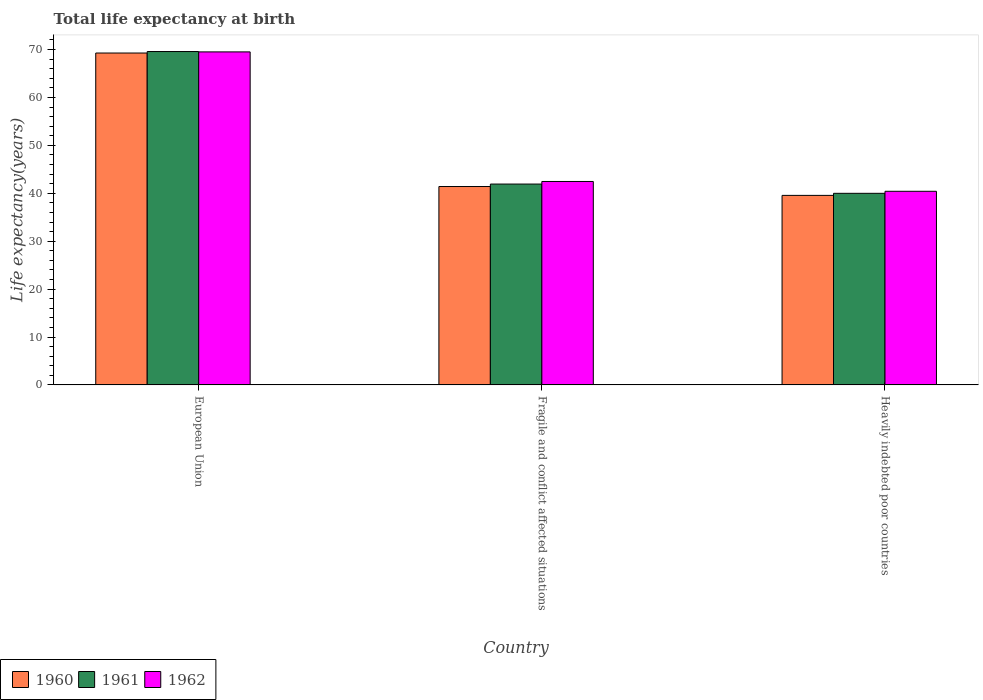How many groups of bars are there?
Offer a very short reply. 3. Are the number of bars on each tick of the X-axis equal?
Make the answer very short. Yes. How many bars are there on the 1st tick from the left?
Offer a very short reply. 3. What is the label of the 1st group of bars from the left?
Offer a very short reply. European Union. In how many cases, is the number of bars for a given country not equal to the number of legend labels?
Offer a terse response. 0. What is the life expectancy at birth in in 1962 in European Union?
Your answer should be compact. 69.51. Across all countries, what is the maximum life expectancy at birth in in 1960?
Provide a short and direct response. 69.28. Across all countries, what is the minimum life expectancy at birth in in 1961?
Provide a succinct answer. 40. In which country was the life expectancy at birth in in 1962 minimum?
Provide a short and direct response. Heavily indebted poor countries. What is the total life expectancy at birth in in 1962 in the graph?
Provide a succinct answer. 152.4. What is the difference between the life expectancy at birth in in 1962 in European Union and that in Fragile and conflict affected situations?
Your answer should be very brief. 27.05. What is the difference between the life expectancy at birth in in 1961 in European Union and the life expectancy at birth in in 1960 in Heavily indebted poor countries?
Ensure brevity in your answer.  30.03. What is the average life expectancy at birth in in 1961 per country?
Provide a succinct answer. 50.5. What is the difference between the life expectancy at birth in of/in 1961 and life expectancy at birth in of/in 1960 in Heavily indebted poor countries?
Your answer should be compact. 0.43. What is the ratio of the life expectancy at birth in in 1961 in Fragile and conflict affected situations to that in Heavily indebted poor countries?
Provide a succinct answer. 1.05. Is the life expectancy at birth in in 1960 in European Union less than that in Fragile and conflict affected situations?
Your answer should be very brief. No. Is the difference between the life expectancy at birth in in 1961 in European Union and Fragile and conflict affected situations greater than the difference between the life expectancy at birth in in 1960 in European Union and Fragile and conflict affected situations?
Offer a very short reply. No. What is the difference between the highest and the second highest life expectancy at birth in in 1960?
Provide a succinct answer. -27.87. What is the difference between the highest and the lowest life expectancy at birth in in 1961?
Provide a short and direct response. 29.59. In how many countries, is the life expectancy at birth in in 1962 greater than the average life expectancy at birth in in 1962 taken over all countries?
Give a very brief answer. 1. What does the 3rd bar from the right in Heavily indebted poor countries represents?
Ensure brevity in your answer.  1960. Is it the case that in every country, the sum of the life expectancy at birth in in 1961 and life expectancy at birth in in 1960 is greater than the life expectancy at birth in in 1962?
Give a very brief answer. Yes. How many bars are there?
Give a very brief answer. 9. How many countries are there in the graph?
Provide a succinct answer. 3. Does the graph contain any zero values?
Your answer should be compact. No. Where does the legend appear in the graph?
Your answer should be compact. Bottom left. How many legend labels are there?
Your response must be concise. 3. What is the title of the graph?
Your response must be concise. Total life expectancy at birth. What is the label or title of the Y-axis?
Your answer should be very brief. Life expectancy(years). What is the Life expectancy(years) of 1960 in European Union?
Your answer should be very brief. 69.28. What is the Life expectancy(years) in 1961 in European Union?
Ensure brevity in your answer.  69.59. What is the Life expectancy(years) in 1962 in European Union?
Your response must be concise. 69.51. What is the Life expectancy(years) in 1960 in Fragile and conflict affected situations?
Provide a succinct answer. 41.41. What is the Life expectancy(years) of 1961 in Fragile and conflict affected situations?
Your answer should be compact. 41.93. What is the Life expectancy(years) in 1962 in Fragile and conflict affected situations?
Your answer should be compact. 42.47. What is the Life expectancy(years) of 1960 in Heavily indebted poor countries?
Ensure brevity in your answer.  39.56. What is the Life expectancy(years) in 1961 in Heavily indebted poor countries?
Your response must be concise. 40. What is the Life expectancy(years) of 1962 in Heavily indebted poor countries?
Your answer should be compact. 40.42. Across all countries, what is the maximum Life expectancy(years) in 1960?
Give a very brief answer. 69.28. Across all countries, what is the maximum Life expectancy(years) in 1961?
Provide a succinct answer. 69.59. Across all countries, what is the maximum Life expectancy(years) in 1962?
Your answer should be compact. 69.51. Across all countries, what is the minimum Life expectancy(years) in 1960?
Provide a succinct answer. 39.56. Across all countries, what is the minimum Life expectancy(years) in 1961?
Your answer should be very brief. 40. Across all countries, what is the minimum Life expectancy(years) in 1962?
Ensure brevity in your answer.  40.42. What is the total Life expectancy(years) in 1960 in the graph?
Ensure brevity in your answer.  150.26. What is the total Life expectancy(years) in 1961 in the graph?
Your answer should be very brief. 151.51. What is the total Life expectancy(years) in 1962 in the graph?
Your response must be concise. 152.4. What is the difference between the Life expectancy(years) of 1960 in European Union and that in Fragile and conflict affected situations?
Ensure brevity in your answer.  27.87. What is the difference between the Life expectancy(years) of 1961 in European Union and that in Fragile and conflict affected situations?
Ensure brevity in your answer.  27.66. What is the difference between the Life expectancy(years) of 1962 in European Union and that in Fragile and conflict affected situations?
Offer a terse response. 27.05. What is the difference between the Life expectancy(years) in 1960 in European Union and that in Heavily indebted poor countries?
Your answer should be very brief. 29.72. What is the difference between the Life expectancy(years) of 1961 in European Union and that in Heavily indebted poor countries?
Your response must be concise. 29.59. What is the difference between the Life expectancy(years) of 1962 in European Union and that in Heavily indebted poor countries?
Keep it short and to the point. 29.1. What is the difference between the Life expectancy(years) in 1960 in Fragile and conflict affected situations and that in Heavily indebted poor countries?
Keep it short and to the point. 1.85. What is the difference between the Life expectancy(years) of 1961 in Fragile and conflict affected situations and that in Heavily indebted poor countries?
Ensure brevity in your answer.  1.93. What is the difference between the Life expectancy(years) in 1962 in Fragile and conflict affected situations and that in Heavily indebted poor countries?
Keep it short and to the point. 2.05. What is the difference between the Life expectancy(years) of 1960 in European Union and the Life expectancy(years) of 1961 in Fragile and conflict affected situations?
Ensure brevity in your answer.  27.35. What is the difference between the Life expectancy(years) in 1960 in European Union and the Life expectancy(years) in 1962 in Fragile and conflict affected situations?
Give a very brief answer. 26.81. What is the difference between the Life expectancy(years) in 1961 in European Union and the Life expectancy(years) in 1962 in Fragile and conflict affected situations?
Provide a short and direct response. 27.12. What is the difference between the Life expectancy(years) in 1960 in European Union and the Life expectancy(years) in 1961 in Heavily indebted poor countries?
Your answer should be compact. 29.28. What is the difference between the Life expectancy(years) in 1960 in European Union and the Life expectancy(years) in 1962 in Heavily indebted poor countries?
Your response must be concise. 28.86. What is the difference between the Life expectancy(years) in 1961 in European Union and the Life expectancy(years) in 1962 in Heavily indebted poor countries?
Provide a short and direct response. 29.17. What is the difference between the Life expectancy(years) in 1960 in Fragile and conflict affected situations and the Life expectancy(years) in 1961 in Heavily indebted poor countries?
Your response must be concise. 1.42. What is the difference between the Life expectancy(years) of 1961 in Fragile and conflict affected situations and the Life expectancy(years) of 1962 in Heavily indebted poor countries?
Make the answer very short. 1.51. What is the average Life expectancy(years) of 1960 per country?
Provide a succinct answer. 50.09. What is the average Life expectancy(years) in 1961 per country?
Your response must be concise. 50.5. What is the average Life expectancy(years) of 1962 per country?
Your answer should be very brief. 50.8. What is the difference between the Life expectancy(years) of 1960 and Life expectancy(years) of 1961 in European Union?
Keep it short and to the point. -0.31. What is the difference between the Life expectancy(years) of 1960 and Life expectancy(years) of 1962 in European Union?
Your answer should be very brief. -0.23. What is the difference between the Life expectancy(years) in 1961 and Life expectancy(years) in 1962 in European Union?
Keep it short and to the point. 0.07. What is the difference between the Life expectancy(years) of 1960 and Life expectancy(years) of 1961 in Fragile and conflict affected situations?
Provide a short and direct response. -0.52. What is the difference between the Life expectancy(years) of 1960 and Life expectancy(years) of 1962 in Fragile and conflict affected situations?
Provide a short and direct response. -1.05. What is the difference between the Life expectancy(years) of 1961 and Life expectancy(years) of 1962 in Fragile and conflict affected situations?
Give a very brief answer. -0.54. What is the difference between the Life expectancy(years) in 1960 and Life expectancy(years) in 1961 in Heavily indebted poor countries?
Your answer should be very brief. -0.43. What is the difference between the Life expectancy(years) of 1960 and Life expectancy(years) of 1962 in Heavily indebted poor countries?
Offer a terse response. -0.86. What is the difference between the Life expectancy(years) of 1961 and Life expectancy(years) of 1962 in Heavily indebted poor countries?
Your answer should be compact. -0.42. What is the ratio of the Life expectancy(years) of 1960 in European Union to that in Fragile and conflict affected situations?
Ensure brevity in your answer.  1.67. What is the ratio of the Life expectancy(years) of 1961 in European Union to that in Fragile and conflict affected situations?
Provide a succinct answer. 1.66. What is the ratio of the Life expectancy(years) in 1962 in European Union to that in Fragile and conflict affected situations?
Offer a very short reply. 1.64. What is the ratio of the Life expectancy(years) in 1960 in European Union to that in Heavily indebted poor countries?
Your response must be concise. 1.75. What is the ratio of the Life expectancy(years) in 1961 in European Union to that in Heavily indebted poor countries?
Your answer should be compact. 1.74. What is the ratio of the Life expectancy(years) of 1962 in European Union to that in Heavily indebted poor countries?
Provide a short and direct response. 1.72. What is the ratio of the Life expectancy(years) of 1960 in Fragile and conflict affected situations to that in Heavily indebted poor countries?
Keep it short and to the point. 1.05. What is the ratio of the Life expectancy(years) in 1961 in Fragile and conflict affected situations to that in Heavily indebted poor countries?
Ensure brevity in your answer.  1.05. What is the ratio of the Life expectancy(years) in 1962 in Fragile and conflict affected situations to that in Heavily indebted poor countries?
Your answer should be very brief. 1.05. What is the difference between the highest and the second highest Life expectancy(years) of 1960?
Your response must be concise. 27.87. What is the difference between the highest and the second highest Life expectancy(years) of 1961?
Make the answer very short. 27.66. What is the difference between the highest and the second highest Life expectancy(years) of 1962?
Your answer should be very brief. 27.05. What is the difference between the highest and the lowest Life expectancy(years) in 1960?
Offer a terse response. 29.72. What is the difference between the highest and the lowest Life expectancy(years) of 1961?
Ensure brevity in your answer.  29.59. What is the difference between the highest and the lowest Life expectancy(years) in 1962?
Offer a very short reply. 29.1. 